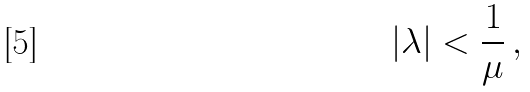<formula> <loc_0><loc_0><loc_500><loc_500>| \lambda | < \frac { 1 } { \mu } \, ,</formula> 